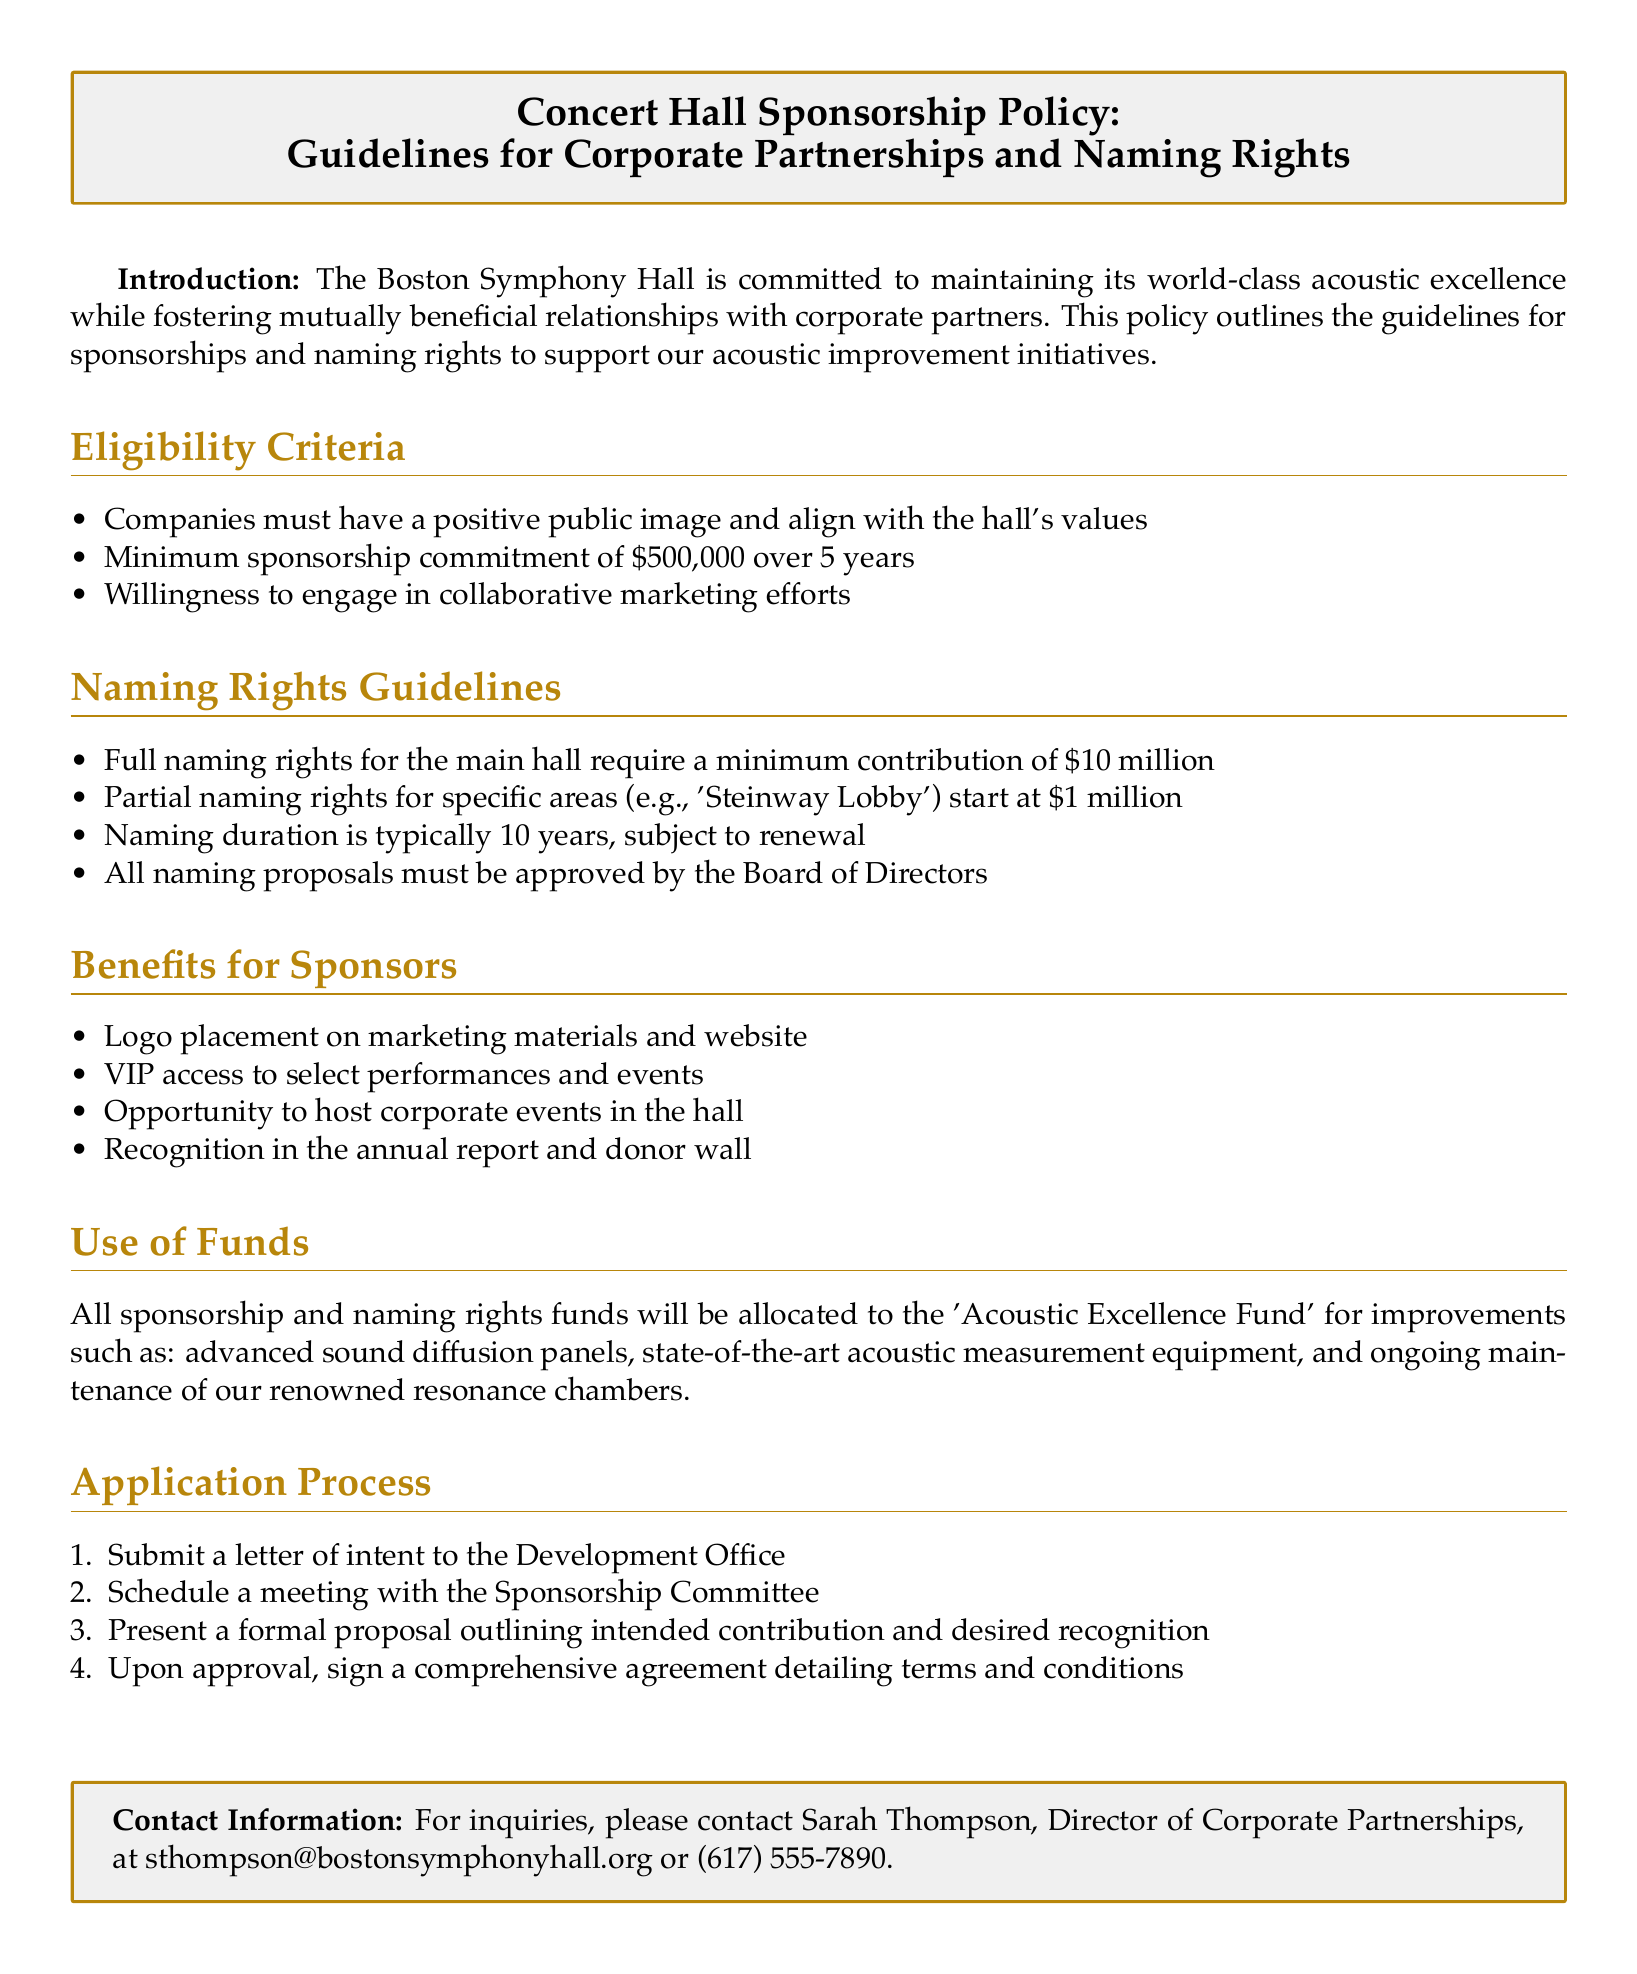What is the minimum sponsorship commitment? The document specifies that the minimum sponsorship commitment is $500,000 over 5 years.
Answer: $500,000 over 5 years What is required for full naming rights of the main hall? The document states that full naming rights for the main hall require a minimum contribution of $10 million.
Answer: $10 million How long is the naming duration typically? According to the document, the naming duration is typically 10 years.
Answer: 10 years Who should be contacted for inquiries about sponsorship? The contact information provided in the document indicates Sarah Thompson as the Director of Corporate Partnerships.
Answer: Sarah Thompson What is one benefit of sponsorship mentioned in the document? The document lists several benefits, one of which is logo placement on marketing materials and website.
Answer: Logo placement on marketing materials and website What is the purpose of the 'Acoustic Excellence Fund'? The document mentions that the Acoustic Excellence Fund is for improvements such as advanced sound diffusion panels.
Answer: Improvements such as advanced sound diffusion panels What is the first step in the application process? The document outlines that the first step is to submit a letter of intent to the Development Office.
Answer: Submit a letter of intent to the Development Office What types of companies are eligible for sponsorship? The eligibility criteria specified in the document include companies having a positive public image and align with the hall's values.
Answer: Positive public image and align with the hall's values What amount does partial naming rights start at? The document states that partial naming rights for specific areas start at $1 million.
Answer: $1 million 